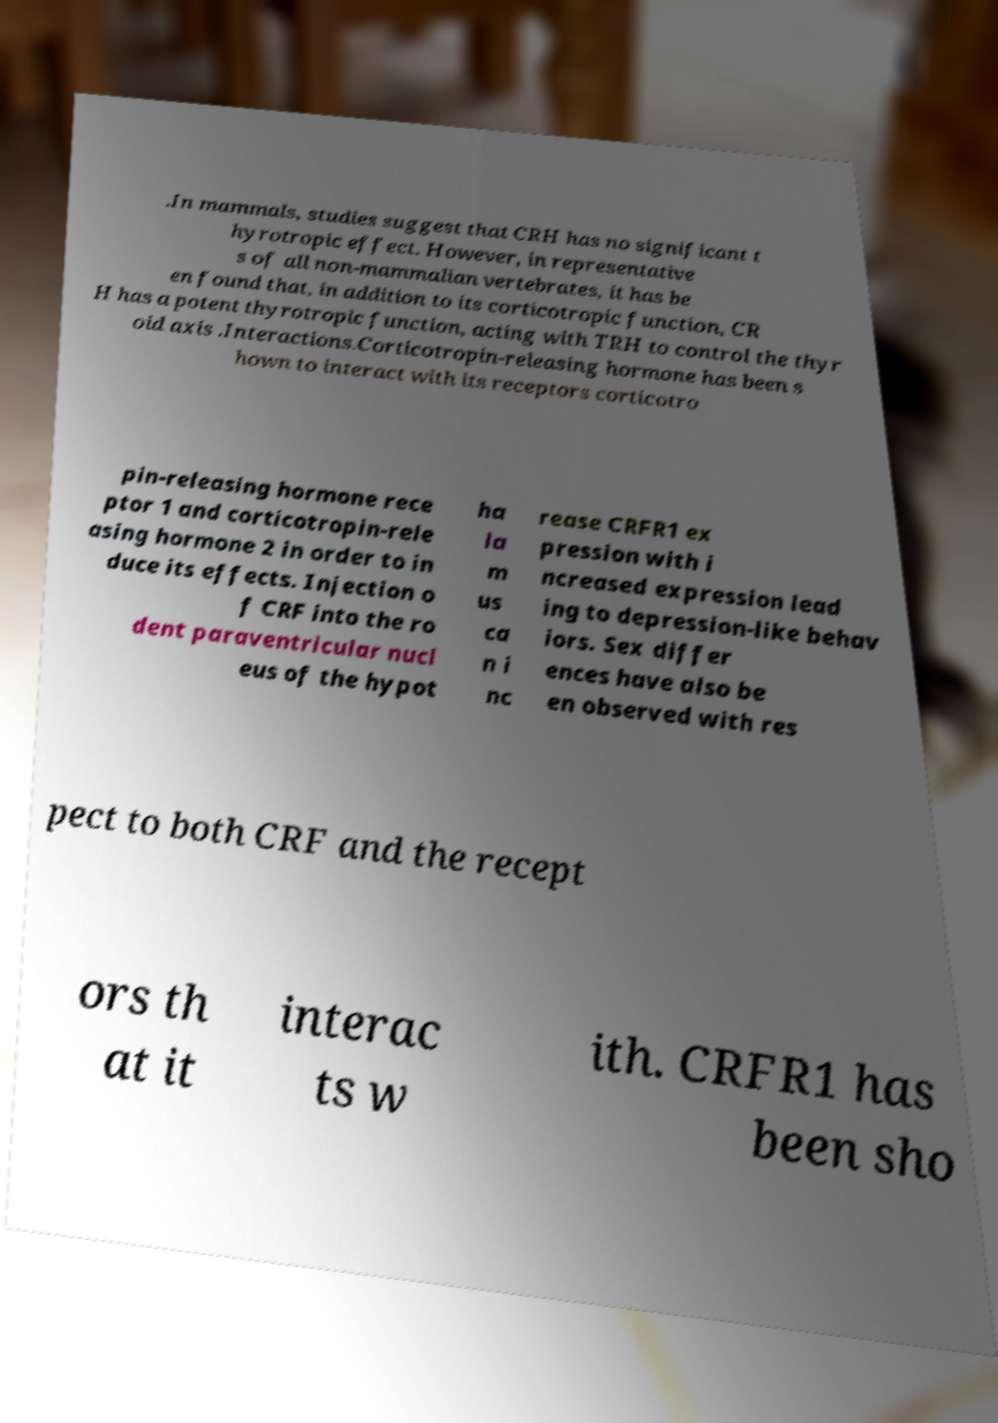What messages or text are displayed in this image? I need them in a readable, typed format. .In mammals, studies suggest that CRH has no significant t hyrotropic effect. However, in representative s of all non-mammalian vertebrates, it has be en found that, in addition to its corticotropic function, CR H has a potent thyrotropic function, acting with TRH to control the thyr oid axis .Interactions.Corticotropin-releasing hormone has been s hown to interact with its receptors corticotro pin-releasing hormone rece ptor 1 and corticotropin-rele asing hormone 2 in order to in duce its effects. Injection o f CRF into the ro dent paraventricular nucl eus of the hypot ha la m us ca n i nc rease CRFR1 ex pression with i ncreased expression lead ing to depression-like behav iors. Sex differ ences have also be en observed with res pect to both CRF and the recept ors th at it interac ts w ith. CRFR1 has been sho 